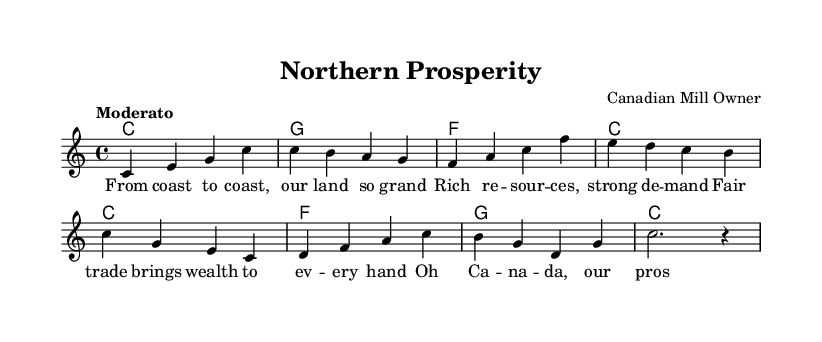What is the key signature of this music? The key signature is indicated by the absence of any sharps or flats in the signature. This means the piece is set in the key of C major.
Answer: C major What is the time signature of this music? The time signature is shown at the beginning and it indicates how many beats are in each measure. In this case, it shows 4/4, which means there are four beats per measure.
Answer: 4/4 What is the tempo marking for this piece? The tempo is specified as "Moderato," which means a moderate speed of performance. This is indicated at the beginning of the score.
Answer: Moderato How many measures are in the melody section? The melody section is composed of eight measures, as it can be counted based on the individual groupings of notes separated by vertical lines in the music.
Answer: 8 What chord does the piece start with? Looking at the chord progression at the beginning, the first chord is indicated as C major, which is the first chord in the harmony section.
Answer: C What is the theme of the lyrics in this piece? The lyrics reflect national pride and economic growth, emphasizing the resources and opportunities in Canada. This can be inferred from the words such as “prosperity” and “fair trade.”
Answer: National pride and economic growth What form does the song primarily follow? The song follows a simple verse structure, evident from the lyrics set under the melody lines with no repeated sections or chorus indicated in the provided excerpt.
Answer: Verse form 